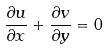<formula> <loc_0><loc_0><loc_500><loc_500>\frac { \partial u } { \partial x } + \frac { \partial v } { \partial y } = 0</formula> 